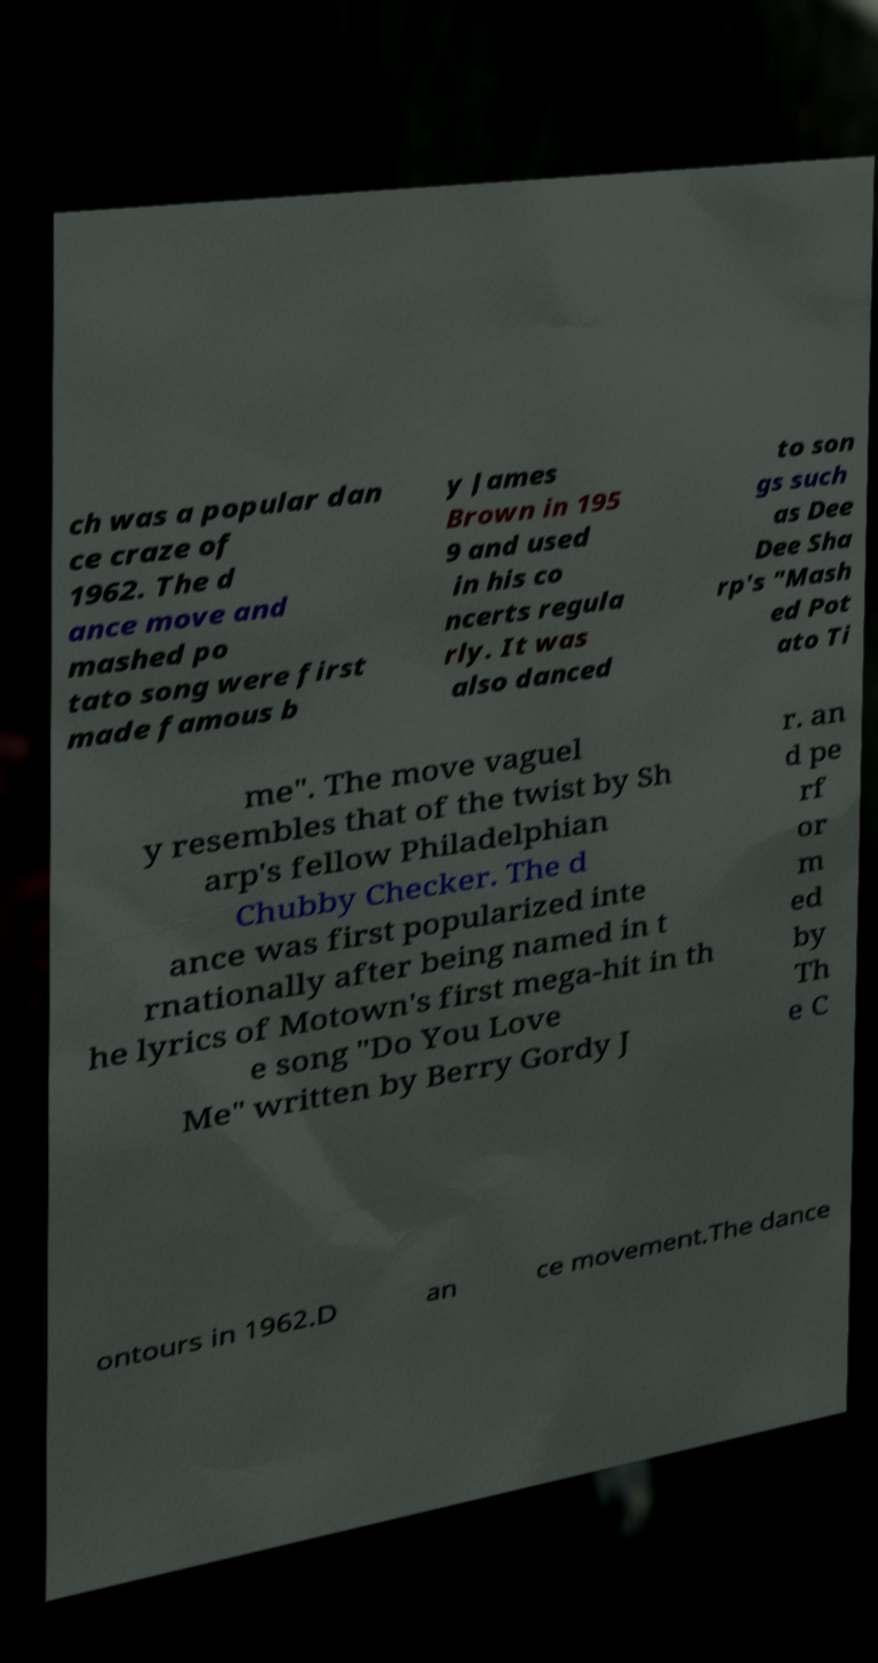I need the written content from this picture converted into text. Can you do that? ch was a popular dan ce craze of 1962. The d ance move and mashed po tato song were first made famous b y James Brown in 195 9 and used in his co ncerts regula rly. It was also danced to son gs such as Dee Dee Sha rp's "Mash ed Pot ato Ti me". The move vaguel y resembles that of the twist by Sh arp's fellow Philadelphian Chubby Checker. The d ance was first popularized inte rnationally after being named in t he lyrics of Motown's first mega-hit in th e song "Do You Love Me" written by Berry Gordy J r. an d pe rf or m ed by Th e C ontours in 1962.D an ce movement.The dance 